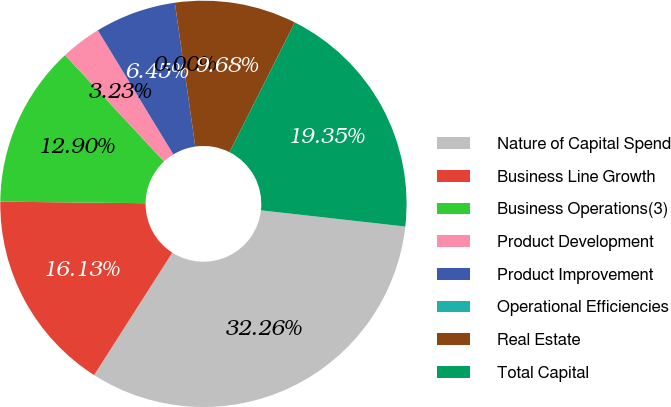Convert chart to OTSL. <chart><loc_0><loc_0><loc_500><loc_500><pie_chart><fcel>Nature of Capital Spend<fcel>Business Line Growth<fcel>Business Operations(3)<fcel>Product Development<fcel>Product Improvement<fcel>Operational Efficiencies<fcel>Real Estate<fcel>Total Capital<nl><fcel>32.26%<fcel>16.13%<fcel>12.9%<fcel>3.23%<fcel>6.45%<fcel>0.0%<fcel>9.68%<fcel>19.35%<nl></chart> 